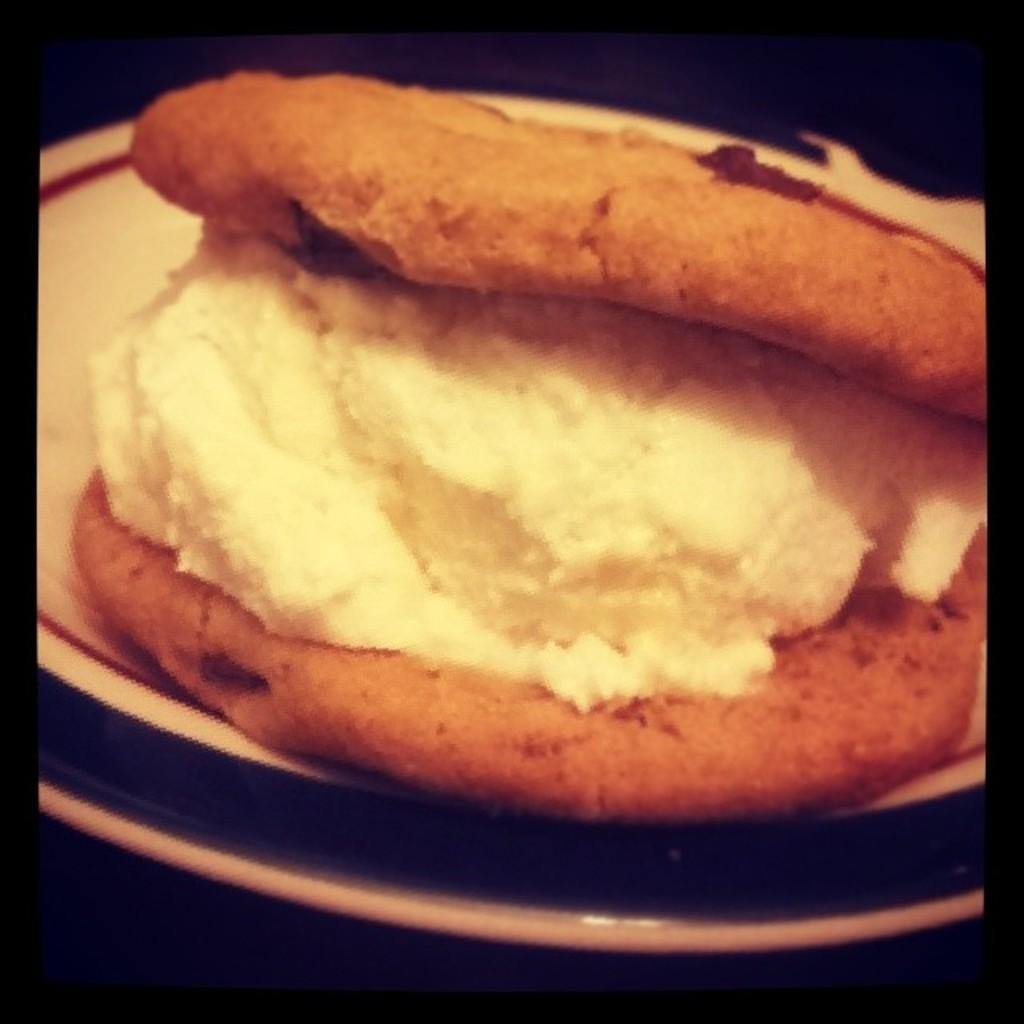What is present on the plate in the image? There is food in a plate in the image. Can you hear the tank moving on the hill in the image? There is no tank or hill present in the image; it only features a plate of food. 